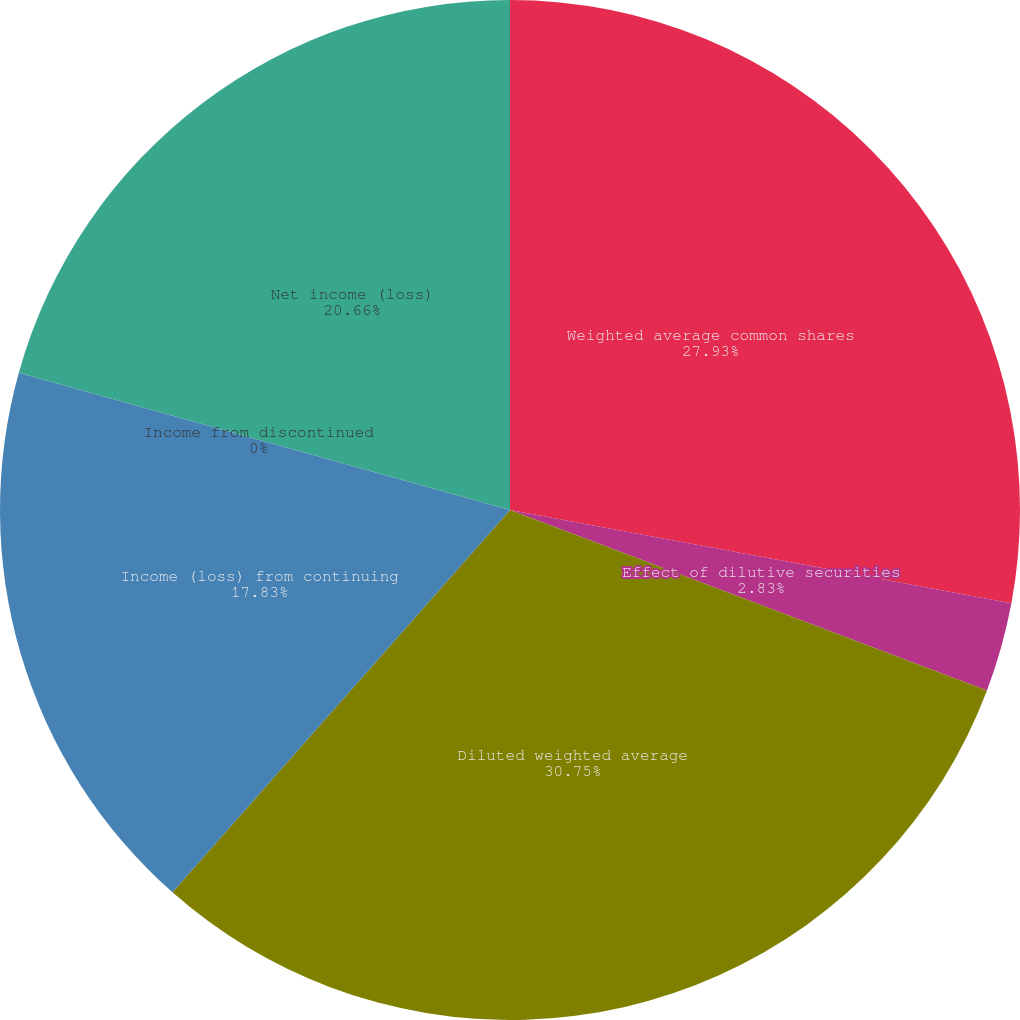Convert chart to OTSL. <chart><loc_0><loc_0><loc_500><loc_500><pie_chart><fcel>Weighted average common shares<fcel>Effect of dilutive securities<fcel>Diluted weighted average<fcel>Income (loss) from continuing<fcel>Income from discontinued<fcel>Net income (loss)<nl><fcel>27.93%<fcel>2.83%<fcel>30.75%<fcel>17.83%<fcel>0.0%<fcel>20.66%<nl></chart> 